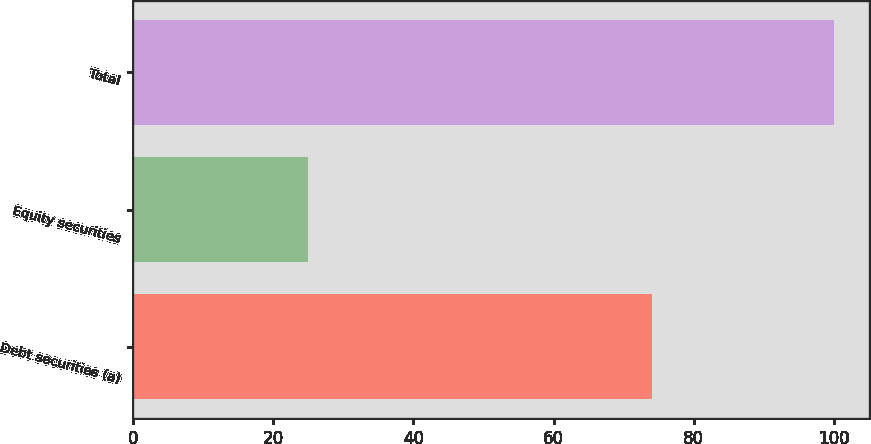Convert chart to OTSL. <chart><loc_0><loc_0><loc_500><loc_500><bar_chart><fcel>Debt securities (a)<fcel>Equity securities<fcel>Total<nl><fcel>74<fcel>25<fcel>100<nl></chart> 